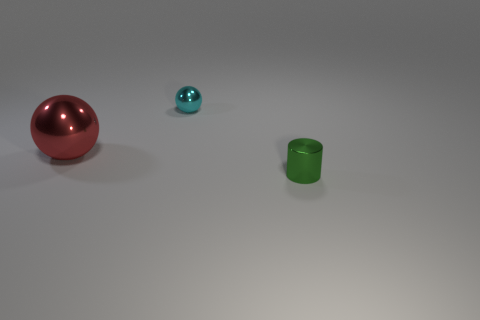Add 1 big red rubber objects. How many objects exist? 4 Subtract all spheres. How many objects are left? 1 Add 1 red objects. How many red objects exist? 2 Subtract 0 purple cylinders. How many objects are left? 3 Subtract all purple rubber objects. Subtract all cyan balls. How many objects are left? 2 Add 1 big things. How many big things are left? 2 